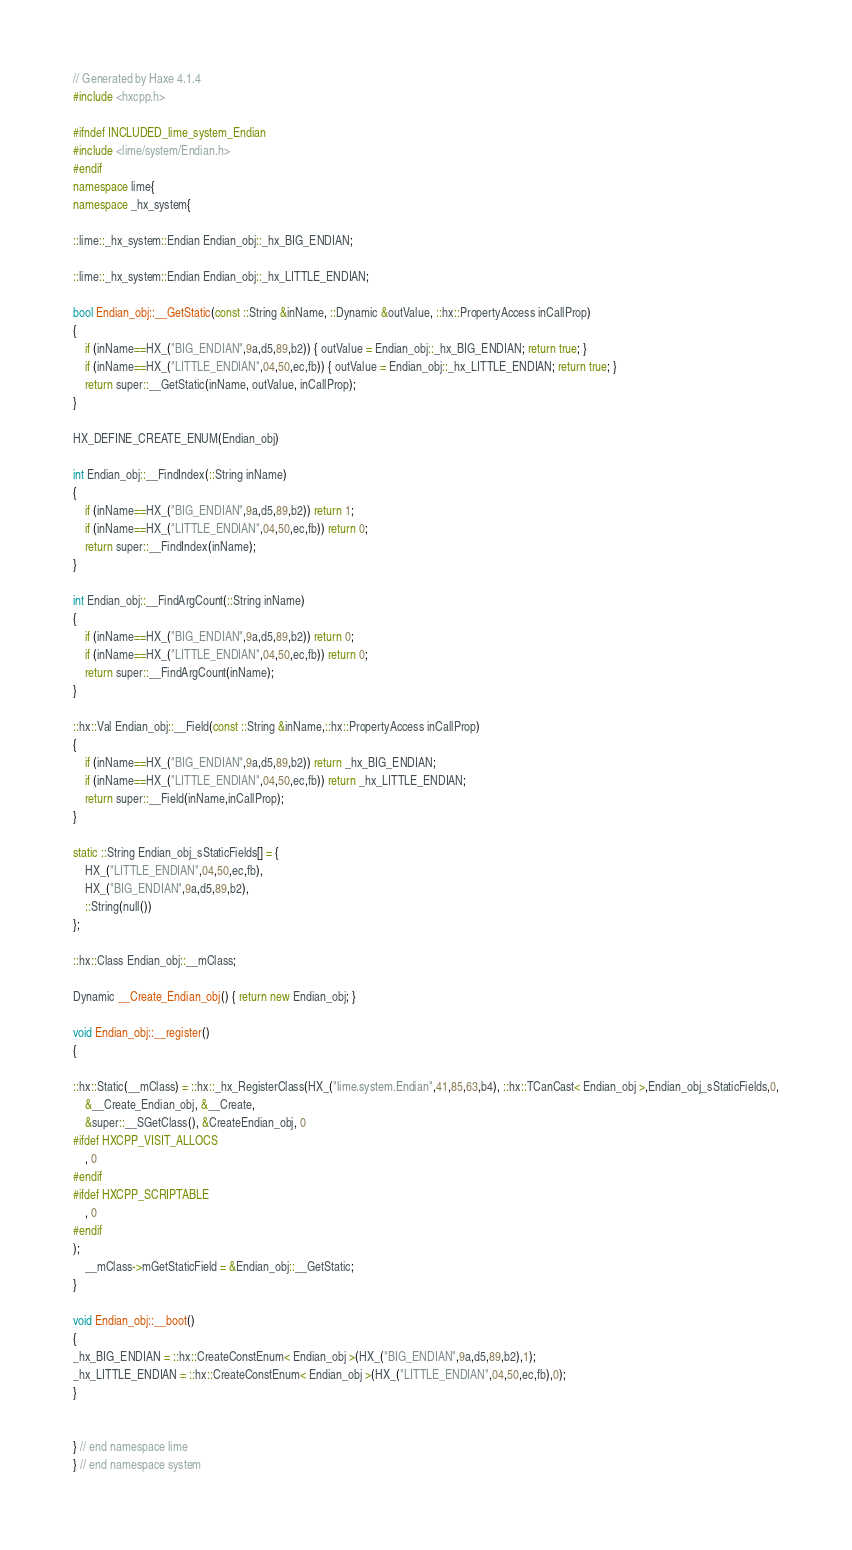Convert code to text. <code><loc_0><loc_0><loc_500><loc_500><_C++_>// Generated by Haxe 4.1.4
#include <hxcpp.h>

#ifndef INCLUDED_lime_system_Endian
#include <lime/system/Endian.h>
#endif
namespace lime{
namespace _hx_system{

::lime::_hx_system::Endian Endian_obj::_hx_BIG_ENDIAN;

::lime::_hx_system::Endian Endian_obj::_hx_LITTLE_ENDIAN;

bool Endian_obj::__GetStatic(const ::String &inName, ::Dynamic &outValue, ::hx::PropertyAccess inCallProp)
{
	if (inName==HX_("BIG_ENDIAN",9a,d5,89,b2)) { outValue = Endian_obj::_hx_BIG_ENDIAN; return true; }
	if (inName==HX_("LITTLE_ENDIAN",04,50,ec,fb)) { outValue = Endian_obj::_hx_LITTLE_ENDIAN; return true; }
	return super::__GetStatic(inName, outValue, inCallProp);
}

HX_DEFINE_CREATE_ENUM(Endian_obj)

int Endian_obj::__FindIndex(::String inName)
{
	if (inName==HX_("BIG_ENDIAN",9a,d5,89,b2)) return 1;
	if (inName==HX_("LITTLE_ENDIAN",04,50,ec,fb)) return 0;
	return super::__FindIndex(inName);
}

int Endian_obj::__FindArgCount(::String inName)
{
	if (inName==HX_("BIG_ENDIAN",9a,d5,89,b2)) return 0;
	if (inName==HX_("LITTLE_ENDIAN",04,50,ec,fb)) return 0;
	return super::__FindArgCount(inName);
}

::hx::Val Endian_obj::__Field(const ::String &inName,::hx::PropertyAccess inCallProp)
{
	if (inName==HX_("BIG_ENDIAN",9a,d5,89,b2)) return _hx_BIG_ENDIAN;
	if (inName==HX_("LITTLE_ENDIAN",04,50,ec,fb)) return _hx_LITTLE_ENDIAN;
	return super::__Field(inName,inCallProp);
}

static ::String Endian_obj_sStaticFields[] = {
	HX_("LITTLE_ENDIAN",04,50,ec,fb),
	HX_("BIG_ENDIAN",9a,d5,89,b2),
	::String(null())
};

::hx::Class Endian_obj::__mClass;

Dynamic __Create_Endian_obj() { return new Endian_obj; }

void Endian_obj::__register()
{

::hx::Static(__mClass) = ::hx::_hx_RegisterClass(HX_("lime.system.Endian",41,85,63,b4), ::hx::TCanCast< Endian_obj >,Endian_obj_sStaticFields,0,
	&__Create_Endian_obj, &__Create,
	&super::__SGetClass(), &CreateEndian_obj, 0
#ifdef HXCPP_VISIT_ALLOCS
    , 0
#endif
#ifdef HXCPP_SCRIPTABLE
    , 0
#endif
);
	__mClass->mGetStaticField = &Endian_obj::__GetStatic;
}

void Endian_obj::__boot()
{
_hx_BIG_ENDIAN = ::hx::CreateConstEnum< Endian_obj >(HX_("BIG_ENDIAN",9a,d5,89,b2),1);
_hx_LITTLE_ENDIAN = ::hx::CreateConstEnum< Endian_obj >(HX_("LITTLE_ENDIAN",04,50,ec,fb),0);
}


} // end namespace lime
} // end namespace system
</code> 